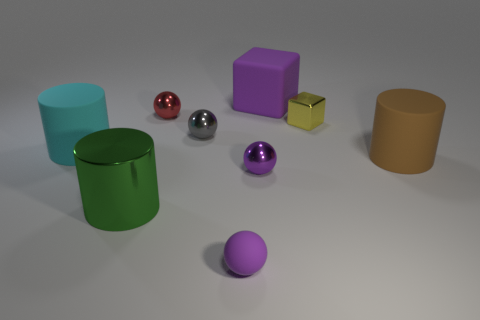Subtract 1 spheres. How many spheres are left? 3 Subtract all green spheres. Subtract all brown cylinders. How many spheres are left? 4 Subtract all balls. How many objects are left? 5 Add 8 big metallic cylinders. How many big metallic cylinders exist? 9 Subtract 1 green cylinders. How many objects are left? 8 Subtract all brown objects. Subtract all rubber things. How many objects are left? 4 Add 7 matte balls. How many matte balls are left? 8 